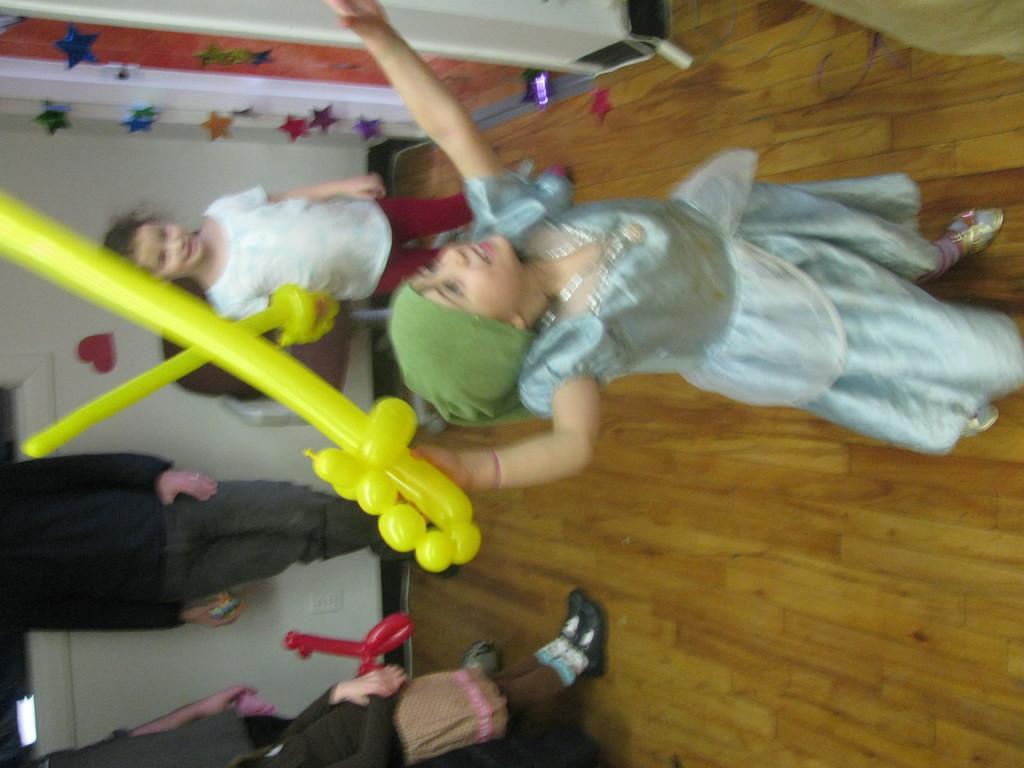How would you summarize this image in a sentence or two? There are two kids standing and holding yellow color object in their hands and there are few other people standing in the left corner. 